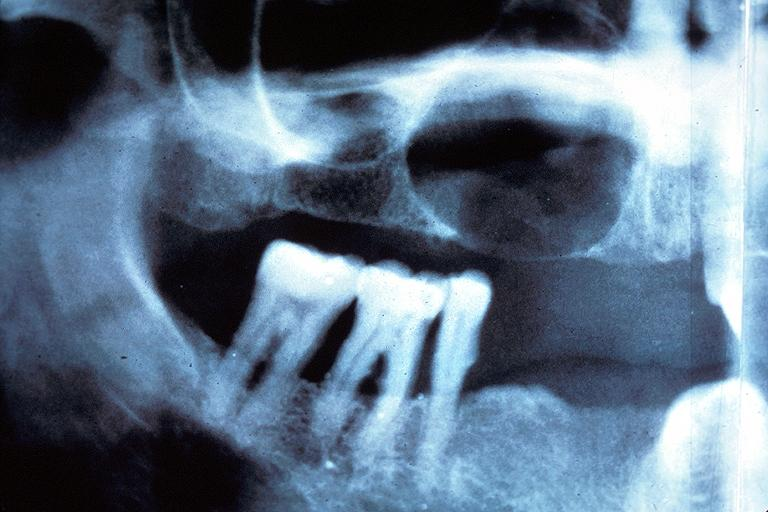s uterus present?
Answer the question using a single word or phrase. No 